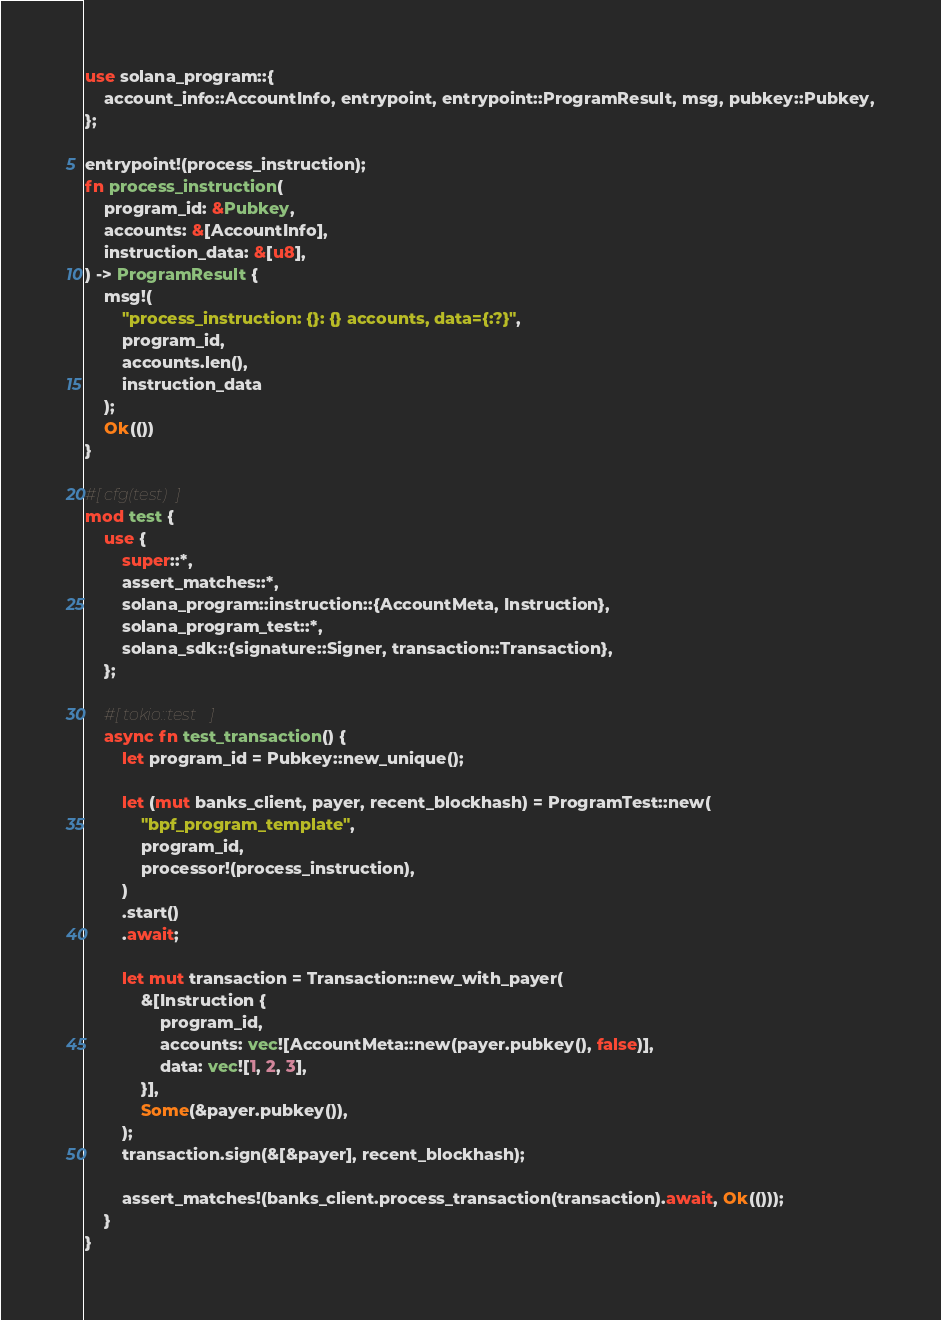Convert code to text. <code><loc_0><loc_0><loc_500><loc_500><_Rust_>use solana_program::{
    account_info::AccountInfo, entrypoint, entrypoint::ProgramResult, msg, pubkey::Pubkey,
};

entrypoint!(process_instruction);
fn process_instruction(
    program_id: &Pubkey,
    accounts: &[AccountInfo],
    instruction_data: &[u8],
) -> ProgramResult {
    msg!(
        "process_instruction: {}: {} accounts, data={:?}",
        program_id,
        accounts.len(),
        instruction_data
    );
    Ok(())
}

#[cfg(test)]
mod test {
    use {
        super::*,
        assert_matches::*,
        solana_program::instruction::{AccountMeta, Instruction},
        solana_program_test::*,
        solana_sdk::{signature::Signer, transaction::Transaction},
    };

    #[tokio::test]
    async fn test_transaction() {
        let program_id = Pubkey::new_unique();

        let (mut banks_client, payer, recent_blockhash) = ProgramTest::new(
            "bpf_program_template",
            program_id,
            processor!(process_instruction),
        )
        .start()
        .await;

        let mut transaction = Transaction::new_with_payer(
            &[Instruction {
                program_id,
                accounts: vec![AccountMeta::new(payer.pubkey(), false)],
                data: vec![1, 2, 3],
            }],
            Some(&payer.pubkey()),
        );
        transaction.sign(&[&payer], recent_blockhash);

        assert_matches!(banks_client.process_transaction(transaction).await, Ok(()));
    }
}</code> 